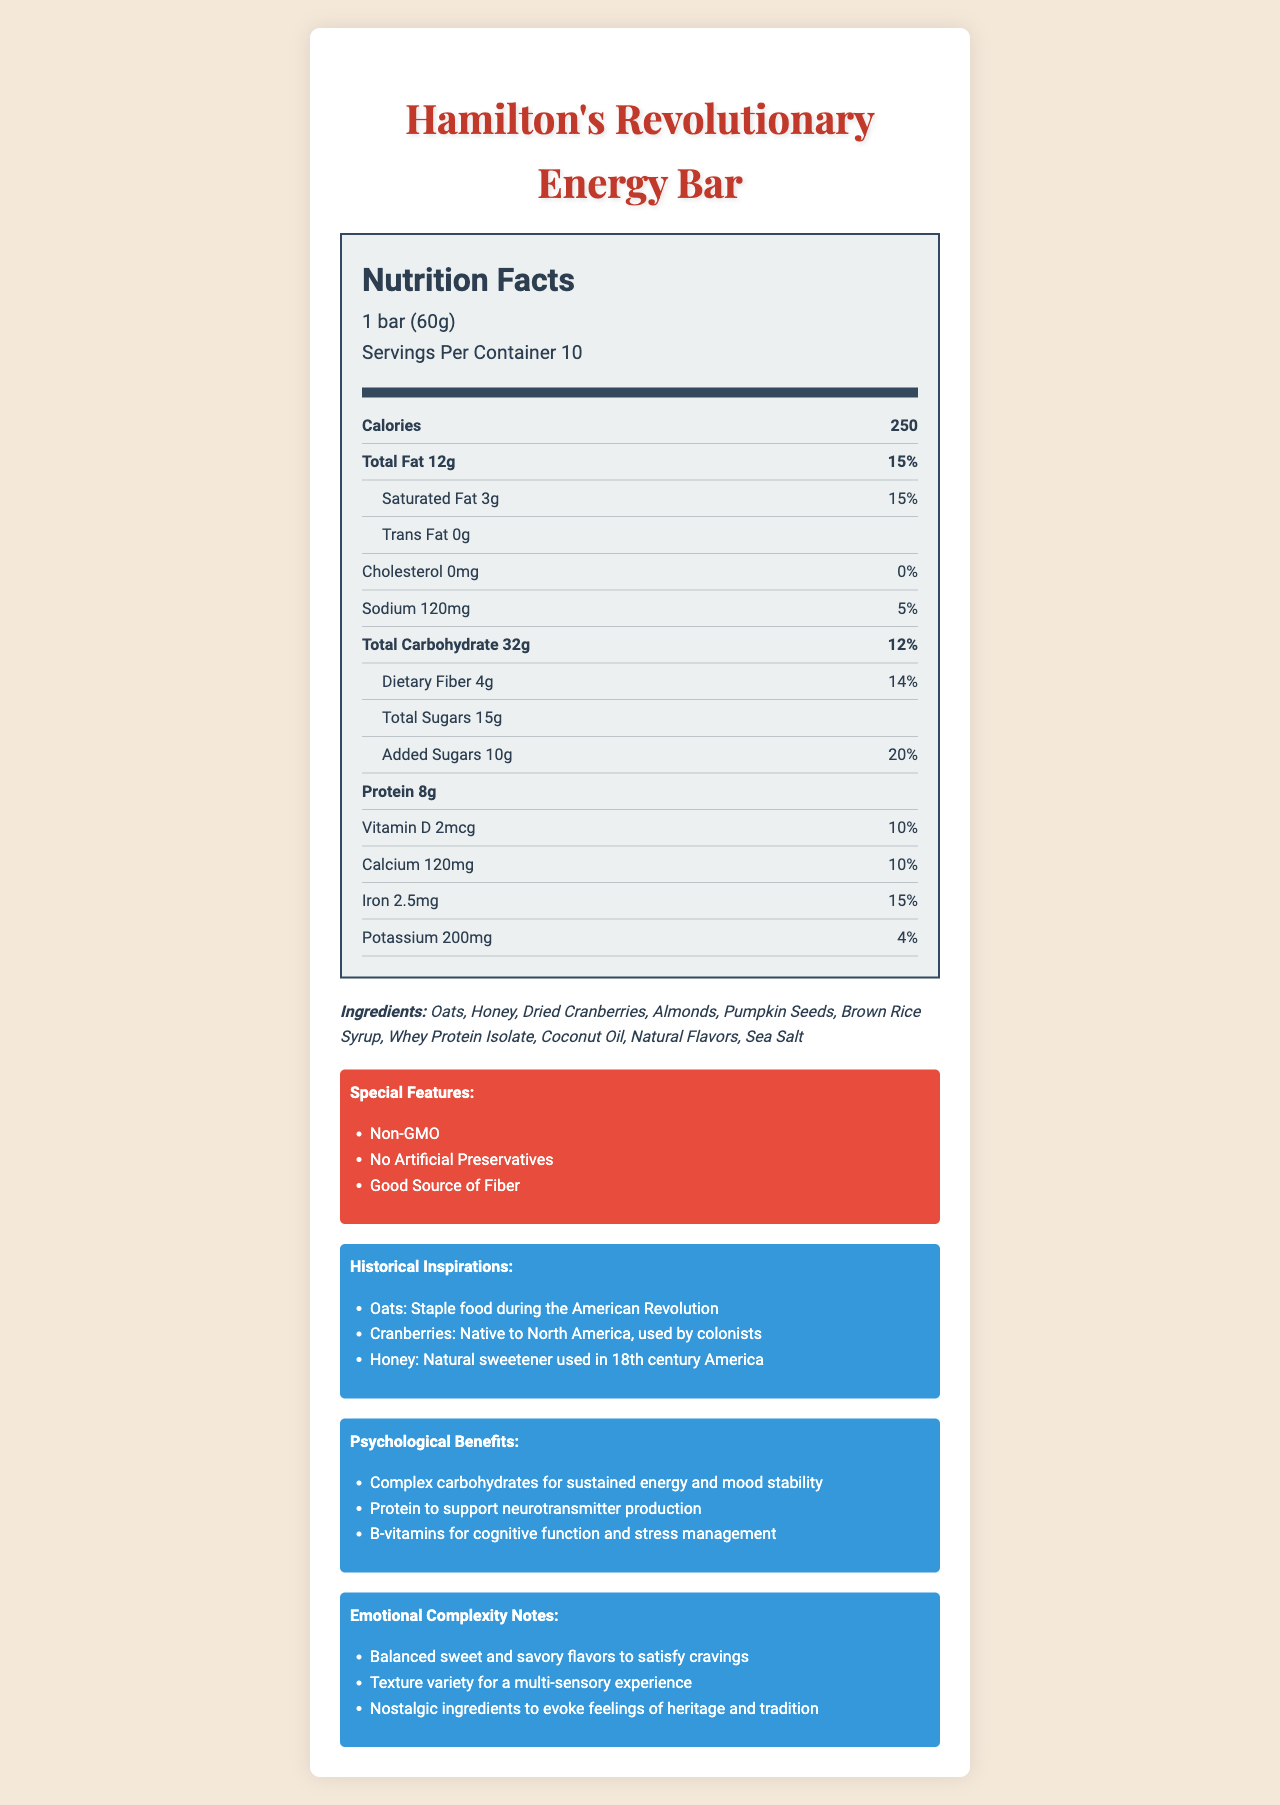what is the serving size of the energy bar? The serving size is explicitly mentioned under the "serving info" section.
Answer: 1 bar (60g) how many calories are in one serving of Hamilton's Revolutionary Energy Bar? The number of calories per serving is listed as 250 in the bold "Calories" section.
Answer: 250 what is the percentage of daily value for saturated fat in one serving? The percentage daily value for saturated fat is provided next to its amount.
Answer: 15% what is the total amount of sugars in one serving? Under the sub-nutrient section, the total sugars are listed as 15g.
Answer: 15g how much protein does one bar contain? The amount of protein per serving is explicitly mentioned in the bold "Protein" section.
Answer: 8g which of the following is a special feature of Hamilton's Revolutionary Energy Bar? A. Low Sodium B. Non-GMO C. High in Protein Non-GMO is listed under the special features section.
Answer: B what are some historical ingredients used in the energy bar according to the document? The historical inspirations section lists oats, cranberries, and honey with their historical context.
Answer: Oats, Cranberries, Honey does the energy bar contain any tree nuts? The allergen information mentions that the bar contains tree nuts (Almonds).
Answer: Yes describe the main idea of the document. The document includes several sections: nutrition facts, ingredient list, special features, historical inspirations, psychological benefits, and emotional complexity notes.
Answer: The document provides detailed nutritional information for Hamilton's Revolutionary Energy Bar, including serving size, calories, and nutrients. It highlights the historical inspirations behind the ingredients, the psychological benefits, emotional complexity notes, and special features like being non-GMO and containing no artificial preservatives. how many grams of dietary fiber are in one serving of the energy bar? The dietary fiber amount is listed as 4g.
Answer: 4g which nutrient has the highest daily value percentage per serving? A. Vitamin D B. Calcium C. Added Sugars D. Iron Added Sugars have the highest daily value percentage at 20%.
Answer: C is the energy bar suitable for someone avoiding milk products? The allergen information indicates that the bar contains milk.
Answer: No what are the psychological benefits mentioned for consuming the bar? The psychological benefits section explicitly lists these benefits.
Answer: Complex carbohydrates for sustained energy and mood stability, Protein to support neurotransmitter production, B-vitamins for cognitive function and stress management how many ingredients are listed in the energy bar? There are 10 ingredients listed under the "Ingredients" section.
Answer: 10 what is the main sweetener used in the energy bar? The historical inspirations mention honey as a natural sweetener.
Answer: Honey what is the percent daily value of iron in one serving? The percent daily value of iron is mentioned in the nutrients section.
Answer: 15% how many special features are listed in the document? A. Two B. Three C. Four There are three special features listed.
Answer: B are there artificial preservatives in the energy bar? One of the special features explicitly states "No Artificial Preservatives".
Answer: No how many servings are there per container of the energy bar? The number of servings per container is listed in the serving info section.
Answer: 10 can the bar's exact flavor be determined based on the document? The document mentions natural flavors but does not specify the exact flavor.
Answer: Not enough information what are the emotional complexity notes for this energy bar? The emotional complexity notes are mentioned under the "Emotional Complexity" section.
Answer: Balanced sweet and savory flavors to satisfy cravings, Texture variety for a multi-sensory experience, Nostalgic ingredients to evoke feelings of heritage and tradition 